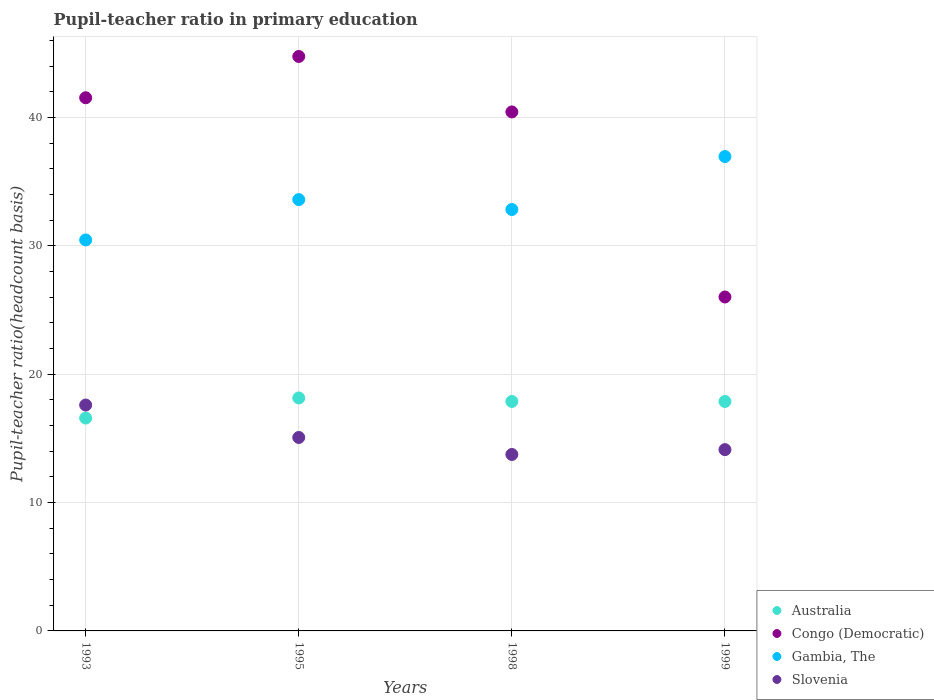What is the pupil-teacher ratio in primary education in Slovenia in 1999?
Offer a terse response. 14.12. Across all years, what is the maximum pupil-teacher ratio in primary education in Slovenia?
Ensure brevity in your answer.  17.6. Across all years, what is the minimum pupil-teacher ratio in primary education in Slovenia?
Keep it short and to the point. 13.75. In which year was the pupil-teacher ratio in primary education in Slovenia maximum?
Your answer should be compact. 1993. In which year was the pupil-teacher ratio in primary education in Slovenia minimum?
Provide a short and direct response. 1998. What is the total pupil-teacher ratio in primary education in Slovenia in the graph?
Make the answer very short. 60.54. What is the difference between the pupil-teacher ratio in primary education in Australia in 1995 and that in 1998?
Your answer should be very brief. 0.27. What is the difference between the pupil-teacher ratio in primary education in Australia in 1998 and the pupil-teacher ratio in primary education in Gambia, The in 1995?
Your answer should be compact. -15.73. What is the average pupil-teacher ratio in primary education in Slovenia per year?
Offer a very short reply. 15.13. In the year 1998, what is the difference between the pupil-teacher ratio in primary education in Gambia, The and pupil-teacher ratio in primary education in Slovenia?
Offer a terse response. 19.08. What is the ratio of the pupil-teacher ratio in primary education in Slovenia in 1993 to that in 1999?
Your answer should be compact. 1.25. Is the pupil-teacher ratio in primary education in Australia in 1998 less than that in 1999?
Provide a succinct answer. Yes. What is the difference between the highest and the second highest pupil-teacher ratio in primary education in Congo (Democratic)?
Provide a succinct answer. 3.22. What is the difference between the highest and the lowest pupil-teacher ratio in primary education in Slovenia?
Offer a terse response. 3.85. In how many years, is the pupil-teacher ratio in primary education in Gambia, The greater than the average pupil-teacher ratio in primary education in Gambia, The taken over all years?
Provide a succinct answer. 2. Is the sum of the pupil-teacher ratio in primary education in Congo (Democratic) in 1993 and 1999 greater than the maximum pupil-teacher ratio in primary education in Australia across all years?
Keep it short and to the point. Yes. Is it the case that in every year, the sum of the pupil-teacher ratio in primary education in Australia and pupil-teacher ratio in primary education in Gambia, The  is greater than the sum of pupil-teacher ratio in primary education in Congo (Democratic) and pupil-teacher ratio in primary education in Slovenia?
Give a very brief answer. Yes. Is it the case that in every year, the sum of the pupil-teacher ratio in primary education in Slovenia and pupil-teacher ratio in primary education in Australia  is greater than the pupil-teacher ratio in primary education in Gambia, The?
Provide a succinct answer. No. Is the pupil-teacher ratio in primary education in Congo (Democratic) strictly greater than the pupil-teacher ratio in primary education in Australia over the years?
Offer a very short reply. Yes. How many years are there in the graph?
Your response must be concise. 4. Are the values on the major ticks of Y-axis written in scientific E-notation?
Provide a short and direct response. No. Does the graph contain grids?
Your answer should be compact. Yes. How many legend labels are there?
Offer a very short reply. 4. What is the title of the graph?
Keep it short and to the point. Pupil-teacher ratio in primary education. What is the label or title of the Y-axis?
Offer a very short reply. Pupil-teacher ratio(headcount basis). What is the Pupil-teacher ratio(headcount basis) of Australia in 1993?
Give a very brief answer. 16.58. What is the Pupil-teacher ratio(headcount basis) of Congo (Democratic) in 1993?
Ensure brevity in your answer.  41.54. What is the Pupil-teacher ratio(headcount basis) in Gambia, The in 1993?
Provide a short and direct response. 30.46. What is the Pupil-teacher ratio(headcount basis) of Slovenia in 1993?
Provide a short and direct response. 17.6. What is the Pupil-teacher ratio(headcount basis) in Australia in 1995?
Give a very brief answer. 18.15. What is the Pupil-teacher ratio(headcount basis) in Congo (Democratic) in 1995?
Provide a short and direct response. 44.75. What is the Pupil-teacher ratio(headcount basis) of Gambia, The in 1995?
Your response must be concise. 33.6. What is the Pupil-teacher ratio(headcount basis) in Slovenia in 1995?
Provide a short and direct response. 15.07. What is the Pupil-teacher ratio(headcount basis) of Australia in 1998?
Ensure brevity in your answer.  17.88. What is the Pupil-teacher ratio(headcount basis) in Congo (Democratic) in 1998?
Give a very brief answer. 40.43. What is the Pupil-teacher ratio(headcount basis) of Gambia, The in 1998?
Give a very brief answer. 32.83. What is the Pupil-teacher ratio(headcount basis) of Slovenia in 1998?
Keep it short and to the point. 13.75. What is the Pupil-teacher ratio(headcount basis) in Australia in 1999?
Keep it short and to the point. 17.88. What is the Pupil-teacher ratio(headcount basis) of Congo (Democratic) in 1999?
Your answer should be very brief. 26.02. What is the Pupil-teacher ratio(headcount basis) in Gambia, The in 1999?
Provide a succinct answer. 36.96. What is the Pupil-teacher ratio(headcount basis) in Slovenia in 1999?
Your answer should be very brief. 14.12. Across all years, what is the maximum Pupil-teacher ratio(headcount basis) of Australia?
Your answer should be very brief. 18.15. Across all years, what is the maximum Pupil-teacher ratio(headcount basis) in Congo (Democratic)?
Your response must be concise. 44.75. Across all years, what is the maximum Pupil-teacher ratio(headcount basis) in Gambia, The?
Make the answer very short. 36.96. Across all years, what is the maximum Pupil-teacher ratio(headcount basis) in Slovenia?
Keep it short and to the point. 17.6. Across all years, what is the minimum Pupil-teacher ratio(headcount basis) in Australia?
Your answer should be very brief. 16.58. Across all years, what is the minimum Pupil-teacher ratio(headcount basis) in Congo (Democratic)?
Keep it short and to the point. 26.02. Across all years, what is the minimum Pupil-teacher ratio(headcount basis) of Gambia, The?
Ensure brevity in your answer.  30.46. Across all years, what is the minimum Pupil-teacher ratio(headcount basis) in Slovenia?
Your answer should be compact. 13.75. What is the total Pupil-teacher ratio(headcount basis) in Australia in the graph?
Keep it short and to the point. 70.48. What is the total Pupil-teacher ratio(headcount basis) of Congo (Democratic) in the graph?
Ensure brevity in your answer.  152.74. What is the total Pupil-teacher ratio(headcount basis) of Gambia, The in the graph?
Make the answer very short. 133.85. What is the total Pupil-teacher ratio(headcount basis) of Slovenia in the graph?
Make the answer very short. 60.54. What is the difference between the Pupil-teacher ratio(headcount basis) in Australia in 1993 and that in 1995?
Give a very brief answer. -1.57. What is the difference between the Pupil-teacher ratio(headcount basis) in Congo (Democratic) in 1993 and that in 1995?
Your response must be concise. -3.22. What is the difference between the Pupil-teacher ratio(headcount basis) in Gambia, The in 1993 and that in 1995?
Offer a very short reply. -3.14. What is the difference between the Pupil-teacher ratio(headcount basis) in Slovenia in 1993 and that in 1995?
Provide a succinct answer. 2.53. What is the difference between the Pupil-teacher ratio(headcount basis) of Australia in 1993 and that in 1998?
Offer a very short reply. -1.29. What is the difference between the Pupil-teacher ratio(headcount basis) of Congo (Democratic) in 1993 and that in 1998?
Your response must be concise. 1.1. What is the difference between the Pupil-teacher ratio(headcount basis) in Gambia, The in 1993 and that in 1998?
Make the answer very short. -2.37. What is the difference between the Pupil-teacher ratio(headcount basis) of Slovenia in 1993 and that in 1998?
Provide a succinct answer. 3.85. What is the difference between the Pupil-teacher ratio(headcount basis) of Australia in 1993 and that in 1999?
Your response must be concise. -1.29. What is the difference between the Pupil-teacher ratio(headcount basis) of Congo (Democratic) in 1993 and that in 1999?
Offer a terse response. 15.52. What is the difference between the Pupil-teacher ratio(headcount basis) in Gambia, The in 1993 and that in 1999?
Provide a succinct answer. -6.5. What is the difference between the Pupil-teacher ratio(headcount basis) in Slovenia in 1993 and that in 1999?
Keep it short and to the point. 3.47. What is the difference between the Pupil-teacher ratio(headcount basis) in Australia in 1995 and that in 1998?
Make the answer very short. 0.27. What is the difference between the Pupil-teacher ratio(headcount basis) of Congo (Democratic) in 1995 and that in 1998?
Make the answer very short. 4.32. What is the difference between the Pupil-teacher ratio(headcount basis) in Gambia, The in 1995 and that in 1998?
Offer a terse response. 0.77. What is the difference between the Pupil-teacher ratio(headcount basis) of Slovenia in 1995 and that in 1998?
Ensure brevity in your answer.  1.32. What is the difference between the Pupil-teacher ratio(headcount basis) in Australia in 1995 and that in 1999?
Keep it short and to the point. 0.27. What is the difference between the Pupil-teacher ratio(headcount basis) of Congo (Democratic) in 1995 and that in 1999?
Offer a very short reply. 18.74. What is the difference between the Pupil-teacher ratio(headcount basis) in Gambia, The in 1995 and that in 1999?
Offer a very short reply. -3.35. What is the difference between the Pupil-teacher ratio(headcount basis) of Slovenia in 1995 and that in 1999?
Offer a terse response. 0.95. What is the difference between the Pupil-teacher ratio(headcount basis) in Australia in 1998 and that in 1999?
Keep it short and to the point. -0. What is the difference between the Pupil-teacher ratio(headcount basis) of Congo (Democratic) in 1998 and that in 1999?
Offer a terse response. 14.42. What is the difference between the Pupil-teacher ratio(headcount basis) in Gambia, The in 1998 and that in 1999?
Your response must be concise. -4.13. What is the difference between the Pupil-teacher ratio(headcount basis) in Slovenia in 1998 and that in 1999?
Your answer should be compact. -0.38. What is the difference between the Pupil-teacher ratio(headcount basis) in Australia in 1993 and the Pupil-teacher ratio(headcount basis) in Congo (Democratic) in 1995?
Give a very brief answer. -28.17. What is the difference between the Pupil-teacher ratio(headcount basis) in Australia in 1993 and the Pupil-teacher ratio(headcount basis) in Gambia, The in 1995?
Keep it short and to the point. -17.02. What is the difference between the Pupil-teacher ratio(headcount basis) of Australia in 1993 and the Pupil-teacher ratio(headcount basis) of Slovenia in 1995?
Make the answer very short. 1.51. What is the difference between the Pupil-teacher ratio(headcount basis) in Congo (Democratic) in 1993 and the Pupil-teacher ratio(headcount basis) in Gambia, The in 1995?
Give a very brief answer. 7.93. What is the difference between the Pupil-teacher ratio(headcount basis) in Congo (Democratic) in 1993 and the Pupil-teacher ratio(headcount basis) in Slovenia in 1995?
Make the answer very short. 26.47. What is the difference between the Pupil-teacher ratio(headcount basis) of Gambia, The in 1993 and the Pupil-teacher ratio(headcount basis) of Slovenia in 1995?
Your answer should be very brief. 15.39. What is the difference between the Pupil-teacher ratio(headcount basis) in Australia in 1993 and the Pupil-teacher ratio(headcount basis) in Congo (Democratic) in 1998?
Your response must be concise. -23.85. What is the difference between the Pupil-teacher ratio(headcount basis) in Australia in 1993 and the Pupil-teacher ratio(headcount basis) in Gambia, The in 1998?
Offer a very short reply. -16.25. What is the difference between the Pupil-teacher ratio(headcount basis) of Australia in 1993 and the Pupil-teacher ratio(headcount basis) of Slovenia in 1998?
Offer a terse response. 2.84. What is the difference between the Pupil-teacher ratio(headcount basis) of Congo (Democratic) in 1993 and the Pupil-teacher ratio(headcount basis) of Gambia, The in 1998?
Keep it short and to the point. 8.71. What is the difference between the Pupil-teacher ratio(headcount basis) of Congo (Democratic) in 1993 and the Pupil-teacher ratio(headcount basis) of Slovenia in 1998?
Your answer should be very brief. 27.79. What is the difference between the Pupil-teacher ratio(headcount basis) of Gambia, The in 1993 and the Pupil-teacher ratio(headcount basis) of Slovenia in 1998?
Provide a short and direct response. 16.71. What is the difference between the Pupil-teacher ratio(headcount basis) of Australia in 1993 and the Pupil-teacher ratio(headcount basis) of Congo (Democratic) in 1999?
Provide a short and direct response. -9.43. What is the difference between the Pupil-teacher ratio(headcount basis) of Australia in 1993 and the Pupil-teacher ratio(headcount basis) of Gambia, The in 1999?
Your response must be concise. -20.37. What is the difference between the Pupil-teacher ratio(headcount basis) in Australia in 1993 and the Pupil-teacher ratio(headcount basis) in Slovenia in 1999?
Provide a succinct answer. 2.46. What is the difference between the Pupil-teacher ratio(headcount basis) in Congo (Democratic) in 1993 and the Pupil-teacher ratio(headcount basis) in Gambia, The in 1999?
Make the answer very short. 4.58. What is the difference between the Pupil-teacher ratio(headcount basis) of Congo (Democratic) in 1993 and the Pupil-teacher ratio(headcount basis) of Slovenia in 1999?
Your response must be concise. 27.41. What is the difference between the Pupil-teacher ratio(headcount basis) of Gambia, The in 1993 and the Pupil-teacher ratio(headcount basis) of Slovenia in 1999?
Your answer should be very brief. 16.34. What is the difference between the Pupil-teacher ratio(headcount basis) of Australia in 1995 and the Pupil-teacher ratio(headcount basis) of Congo (Democratic) in 1998?
Your response must be concise. -22.28. What is the difference between the Pupil-teacher ratio(headcount basis) of Australia in 1995 and the Pupil-teacher ratio(headcount basis) of Gambia, The in 1998?
Your answer should be compact. -14.68. What is the difference between the Pupil-teacher ratio(headcount basis) of Australia in 1995 and the Pupil-teacher ratio(headcount basis) of Slovenia in 1998?
Make the answer very short. 4.4. What is the difference between the Pupil-teacher ratio(headcount basis) in Congo (Democratic) in 1995 and the Pupil-teacher ratio(headcount basis) in Gambia, The in 1998?
Keep it short and to the point. 11.92. What is the difference between the Pupil-teacher ratio(headcount basis) of Congo (Democratic) in 1995 and the Pupil-teacher ratio(headcount basis) of Slovenia in 1998?
Offer a very short reply. 31.01. What is the difference between the Pupil-teacher ratio(headcount basis) of Gambia, The in 1995 and the Pupil-teacher ratio(headcount basis) of Slovenia in 1998?
Provide a succinct answer. 19.86. What is the difference between the Pupil-teacher ratio(headcount basis) of Australia in 1995 and the Pupil-teacher ratio(headcount basis) of Congo (Democratic) in 1999?
Your response must be concise. -7.87. What is the difference between the Pupil-teacher ratio(headcount basis) in Australia in 1995 and the Pupil-teacher ratio(headcount basis) in Gambia, The in 1999?
Provide a short and direct response. -18.81. What is the difference between the Pupil-teacher ratio(headcount basis) of Australia in 1995 and the Pupil-teacher ratio(headcount basis) of Slovenia in 1999?
Provide a short and direct response. 4.03. What is the difference between the Pupil-teacher ratio(headcount basis) in Congo (Democratic) in 1995 and the Pupil-teacher ratio(headcount basis) in Gambia, The in 1999?
Offer a terse response. 7.8. What is the difference between the Pupil-teacher ratio(headcount basis) of Congo (Democratic) in 1995 and the Pupil-teacher ratio(headcount basis) of Slovenia in 1999?
Give a very brief answer. 30.63. What is the difference between the Pupil-teacher ratio(headcount basis) in Gambia, The in 1995 and the Pupil-teacher ratio(headcount basis) in Slovenia in 1999?
Offer a very short reply. 19.48. What is the difference between the Pupil-teacher ratio(headcount basis) in Australia in 1998 and the Pupil-teacher ratio(headcount basis) in Congo (Democratic) in 1999?
Offer a very short reply. -8.14. What is the difference between the Pupil-teacher ratio(headcount basis) of Australia in 1998 and the Pupil-teacher ratio(headcount basis) of Gambia, The in 1999?
Give a very brief answer. -19.08. What is the difference between the Pupil-teacher ratio(headcount basis) in Australia in 1998 and the Pupil-teacher ratio(headcount basis) in Slovenia in 1999?
Provide a succinct answer. 3.75. What is the difference between the Pupil-teacher ratio(headcount basis) of Congo (Democratic) in 1998 and the Pupil-teacher ratio(headcount basis) of Gambia, The in 1999?
Offer a very short reply. 3.48. What is the difference between the Pupil-teacher ratio(headcount basis) of Congo (Democratic) in 1998 and the Pupil-teacher ratio(headcount basis) of Slovenia in 1999?
Ensure brevity in your answer.  26.31. What is the difference between the Pupil-teacher ratio(headcount basis) in Gambia, The in 1998 and the Pupil-teacher ratio(headcount basis) in Slovenia in 1999?
Give a very brief answer. 18.71. What is the average Pupil-teacher ratio(headcount basis) in Australia per year?
Offer a very short reply. 17.62. What is the average Pupil-teacher ratio(headcount basis) of Congo (Democratic) per year?
Keep it short and to the point. 38.18. What is the average Pupil-teacher ratio(headcount basis) of Gambia, The per year?
Make the answer very short. 33.46. What is the average Pupil-teacher ratio(headcount basis) of Slovenia per year?
Offer a terse response. 15.13. In the year 1993, what is the difference between the Pupil-teacher ratio(headcount basis) of Australia and Pupil-teacher ratio(headcount basis) of Congo (Democratic)?
Make the answer very short. -24.95. In the year 1993, what is the difference between the Pupil-teacher ratio(headcount basis) in Australia and Pupil-teacher ratio(headcount basis) in Gambia, The?
Offer a terse response. -13.88. In the year 1993, what is the difference between the Pupil-teacher ratio(headcount basis) of Australia and Pupil-teacher ratio(headcount basis) of Slovenia?
Your answer should be compact. -1.02. In the year 1993, what is the difference between the Pupil-teacher ratio(headcount basis) of Congo (Democratic) and Pupil-teacher ratio(headcount basis) of Gambia, The?
Your response must be concise. 11.08. In the year 1993, what is the difference between the Pupil-teacher ratio(headcount basis) in Congo (Democratic) and Pupil-teacher ratio(headcount basis) in Slovenia?
Your answer should be very brief. 23.94. In the year 1993, what is the difference between the Pupil-teacher ratio(headcount basis) in Gambia, The and Pupil-teacher ratio(headcount basis) in Slovenia?
Your response must be concise. 12.86. In the year 1995, what is the difference between the Pupil-teacher ratio(headcount basis) in Australia and Pupil-teacher ratio(headcount basis) in Congo (Democratic)?
Keep it short and to the point. -26.6. In the year 1995, what is the difference between the Pupil-teacher ratio(headcount basis) in Australia and Pupil-teacher ratio(headcount basis) in Gambia, The?
Make the answer very short. -15.45. In the year 1995, what is the difference between the Pupil-teacher ratio(headcount basis) in Australia and Pupil-teacher ratio(headcount basis) in Slovenia?
Offer a very short reply. 3.08. In the year 1995, what is the difference between the Pupil-teacher ratio(headcount basis) of Congo (Democratic) and Pupil-teacher ratio(headcount basis) of Gambia, The?
Your response must be concise. 11.15. In the year 1995, what is the difference between the Pupil-teacher ratio(headcount basis) of Congo (Democratic) and Pupil-teacher ratio(headcount basis) of Slovenia?
Keep it short and to the point. 29.68. In the year 1995, what is the difference between the Pupil-teacher ratio(headcount basis) of Gambia, The and Pupil-teacher ratio(headcount basis) of Slovenia?
Your response must be concise. 18.53. In the year 1998, what is the difference between the Pupil-teacher ratio(headcount basis) of Australia and Pupil-teacher ratio(headcount basis) of Congo (Democratic)?
Provide a succinct answer. -22.56. In the year 1998, what is the difference between the Pupil-teacher ratio(headcount basis) of Australia and Pupil-teacher ratio(headcount basis) of Gambia, The?
Give a very brief answer. -14.96. In the year 1998, what is the difference between the Pupil-teacher ratio(headcount basis) of Australia and Pupil-teacher ratio(headcount basis) of Slovenia?
Your answer should be compact. 4.13. In the year 1998, what is the difference between the Pupil-teacher ratio(headcount basis) in Congo (Democratic) and Pupil-teacher ratio(headcount basis) in Gambia, The?
Make the answer very short. 7.6. In the year 1998, what is the difference between the Pupil-teacher ratio(headcount basis) in Congo (Democratic) and Pupil-teacher ratio(headcount basis) in Slovenia?
Offer a terse response. 26.69. In the year 1998, what is the difference between the Pupil-teacher ratio(headcount basis) in Gambia, The and Pupil-teacher ratio(headcount basis) in Slovenia?
Your answer should be compact. 19.08. In the year 1999, what is the difference between the Pupil-teacher ratio(headcount basis) of Australia and Pupil-teacher ratio(headcount basis) of Congo (Democratic)?
Offer a very short reply. -8.14. In the year 1999, what is the difference between the Pupil-teacher ratio(headcount basis) of Australia and Pupil-teacher ratio(headcount basis) of Gambia, The?
Your answer should be compact. -19.08. In the year 1999, what is the difference between the Pupil-teacher ratio(headcount basis) in Australia and Pupil-teacher ratio(headcount basis) in Slovenia?
Provide a short and direct response. 3.75. In the year 1999, what is the difference between the Pupil-teacher ratio(headcount basis) in Congo (Democratic) and Pupil-teacher ratio(headcount basis) in Gambia, The?
Your answer should be compact. -10.94. In the year 1999, what is the difference between the Pupil-teacher ratio(headcount basis) of Congo (Democratic) and Pupil-teacher ratio(headcount basis) of Slovenia?
Your response must be concise. 11.89. In the year 1999, what is the difference between the Pupil-teacher ratio(headcount basis) in Gambia, The and Pupil-teacher ratio(headcount basis) in Slovenia?
Your response must be concise. 22.83. What is the ratio of the Pupil-teacher ratio(headcount basis) in Australia in 1993 to that in 1995?
Your answer should be very brief. 0.91. What is the ratio of the Pupil-teacher ratio(headcount basis) of Congo (Democratic) in 1993 to that in 1995?
Ensure brevity in your answer.  0.93. What is the ratio of the Pupil-teacher ratio(headcount basis) of Gambia, The in 1993 to that in 1995?
Provide a short and direct response. 0.91. What is the ratio of the Pupil-teacher ratio(headcount basis) in Slovenia in 1993 to that in 1995?
Give a very brief answer. 1.17. What is the ratio of the Pupil-teacher ratio(headcount basis) in Australia in 1993 to that in 1998?
Provide a succinct answer. 0.93. What is the ratio of the Pupil-teacher ratio(headcount basis) in Congo (Democratic) in 1993 to that in 1998?
Provide a succinct answer. 1.03. What is the ratio of the Pupil-teacher ratio(headcount basis) in Gambia, The in 1993 to that in 1998?
Make the answer very short. 0.93. What is the ratio of the Pupil-teacher ratio(headcount basis) in Slovenia in 1993 to that in 1998?
Your response must be concise. 1.28. What is the ratio of the Pupil-teacher ratio(headcount basis) of Australia in 1993 to that in 1999?
Provide a succinct answer. 0.93. What is the ratio of the Pupil-teacher ratio(headcount basis) in Congo (Democratic) in 1993 to that in 1999?
Offer a terse response. 1.6. What is the ratio of the Pupil-teacher ratio(headcount basis) of Gambia, The in 1993 to that in 1999?
Provide a succinct answer. 0.82. What is the ratio of the Pupil-teacher ratio(headcount basis) in Slovenia in 1993 to that in 1999?
Ensure brevity in your answer.  1.25. What is the ratio of the Pupil-teacher ratio(headcount basis) in Australia in 1995 to that in 1998?
Keep it short and to the point. 1.02. What is the ratio of the Pupil-teacher ratio(headcount basis) in Congo (Democratic) in 1995 to that in 1998?
Your response must be concise. 1.11. What is the ratio of the Pupil-teacher ratio(headcount basis) of Gambia, The in 1995 to that in 1998?
Your answer should be compact. 1.02. What is the ratio of the Pupil-teacher ratio(headcount basis) in Slovenia in 1995 to that in 1998?
Your response must be concise. 1.1. What is the ratio of the Pupil-teacher ratio(headcount basis) in Australia in 1995 to that in 1999?
Offer a terse response. 1.02. What is the ratio of the Pupil-teacher ratio(headcount basis) of Congo (Democratic) in 1995 to that in 1999?
Your answer should be very brief. 1.72. What is the ratio of the Pupil-teacher ratio(headcount basis) of Gambia, The in 1995 to that in 1999?
Your answer should be very brief. 0.91. What is the ratio of the Pupil-teacher ratio(headcount basis) of Slovenia in 1995 to that in 1999?
Your answer should be very brief. 1.07. What is the ratio of the Pupil-teacher ratio(headcount basis) of Australia in 1998 to that in 1999?
Offer a very short reply. 1. What is the ratio of the Pupil-teacher ratio(headcount basis) in Congo (Democratic) in 1998 to that in 1999?
Provide a succinct answer. 1.55. What is the ratio of the Pupil-teacher ratio(headcount basis) in Gambia, The in 1998 to that in 1999?
Your answer should be very brief. 0.89. What is the ratio of the Pupil-teacher ratio(headcount basis) of Slovenia in 1998 to that in 1999?
Offer a very short reply. 0.97. What is the difference between the highest and the second highest Pupil-teacher ratio(headcount basis) in Australia?
Offer a terse response. 0.27. What is the difference between the highest and the second highest Pupil-teacher ratio(headcount basis) in Congo (Democratic)?
Your answer should be compact. 3.22. What is the difference between the highest and the second highest Pupil-teacher ratio(headcount basis) in Gambia, The?
Offer a terse response. 3.35. What is the difference between the highest and the second highest Pupil-teacher ratio(headcount basis) in Slovenia?
Your answer should be very brief. 2.53. What is the difference between the highest and the lowest Pupil-teacher ratio(headcount basis) in Australia?
Give a very brief answer. 1.57. What is the difference between the highest and the lowest Pupil-teacher ratio(headcount basis) of Congo (Democratic)?
Your answer should be very brief. 18.74. What is the difference between the highest and the lowest Pupil-teacher ratio(headcount basis) of Gambia, The?
Your answer should be very brief. 6.5. What is the difference between the highest and the lowest Pupil-teacher ratio(headcount basis) of Slovenia?
Provide a succinct answer. 3.85. 